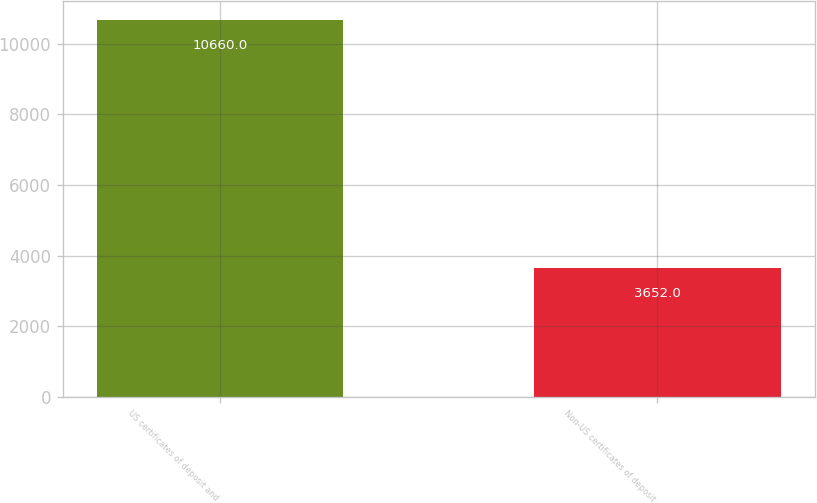Convert chart to OTSL. <chart><loc_0><loc_0><loc_500><loc_500><bar_chart><fcel>US certificates of deposit and<fcel>Non-US certificates of deposit<nl><fcel>10660<fcel>3652<nl></chart> 